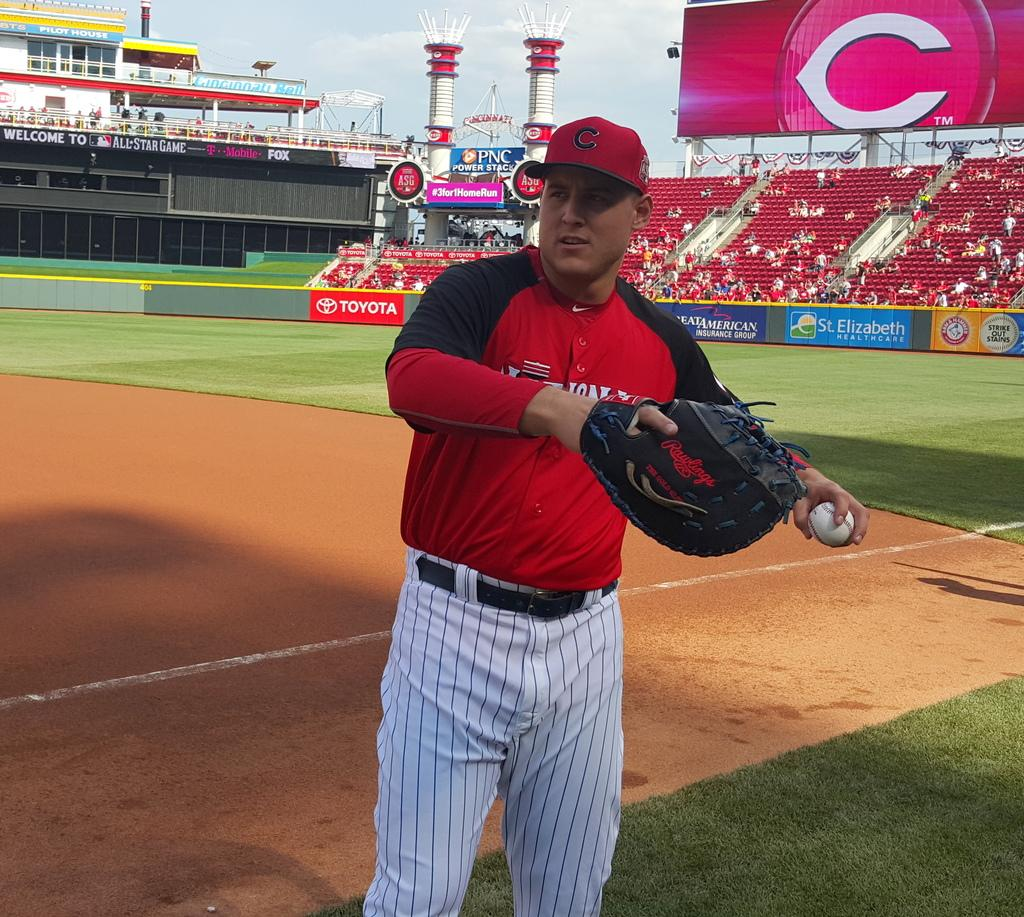<image>
Relay a brief, clear account of the picture shown. a man about to throw a ball on a field sponsored by TOYOTA 